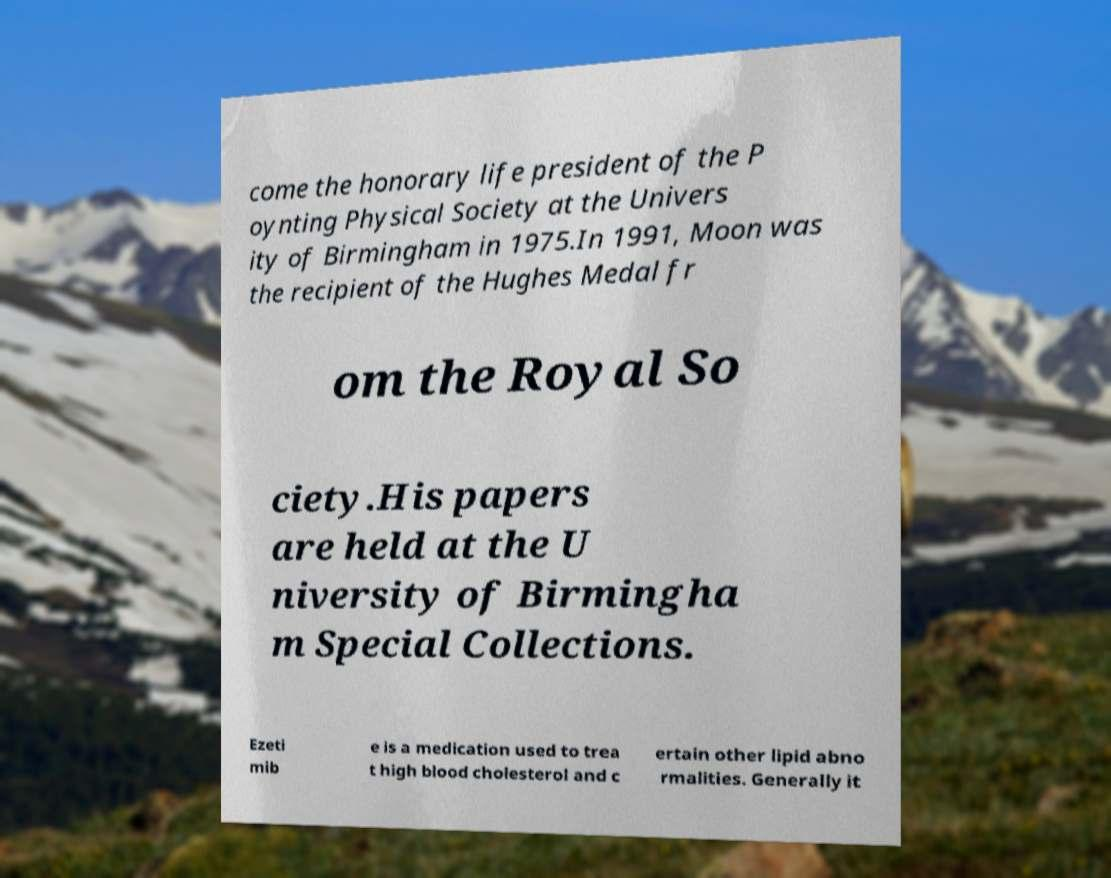There's text embedded in this image that I need extracted. Can you transcribe it verbatim? come the honorary life president of the P oynting Physical Society at the Univers ity of Birmingham in 1975.In 1991, Moon was the recipient of the Hughes Medal fr om the Royal So ciety.His papers are held at the U niversity of Birmingha m Special Collections. Ezeti mib e is a medication used to trea t high blood cholesterol and c ertain other lipid abno rmalities. Generally it 